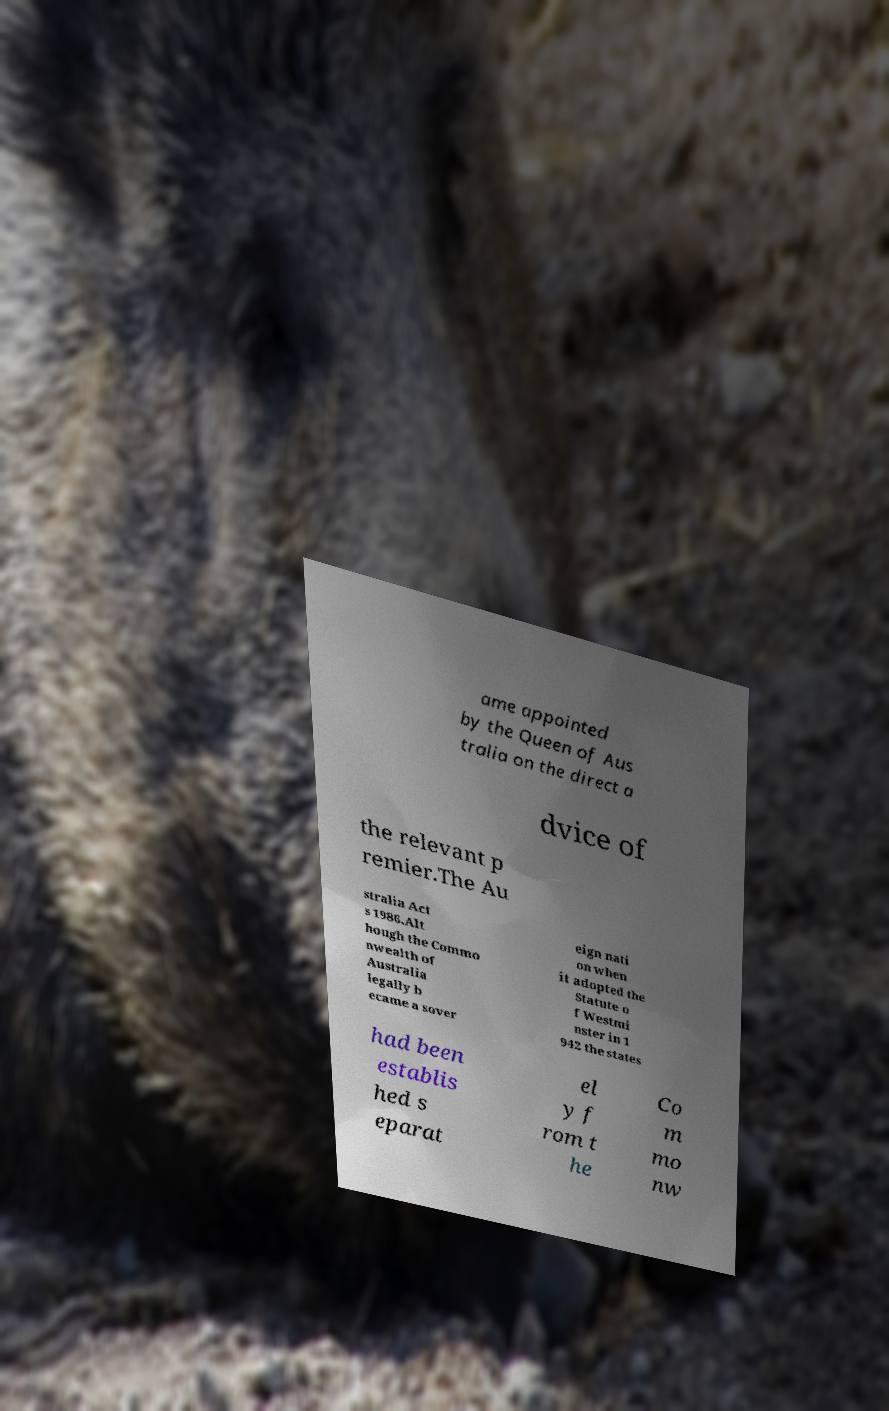There's text embedded in this image that I need extracted. Can you transcribe it verbatim? ame appointed by the Queen of Aus tralia on the direct a dvice of the relevant p remier.The Au stralia Act s 1986.Alt hough the Commo nwealth of Australia legally b ecame a sover eign nati on when it adopted the Statute o f Westmi nster in 1 942 the states had been establis hed s eparat el y f rom t he Co m mo nw 